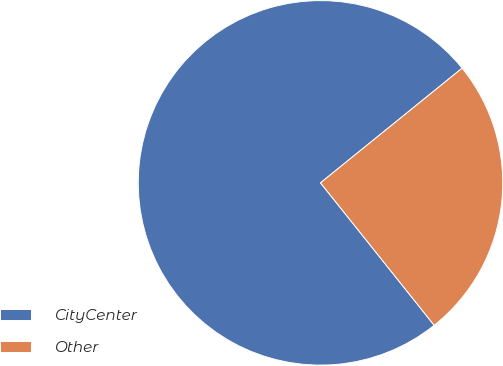Convert chart. <chart><loc_0><loc_0><loc_500><loc_500><pie_chart><fcel>CityCenter<fcel>Other<nl><fcel>74.89%<fcel>25.11%<nl></chart> 